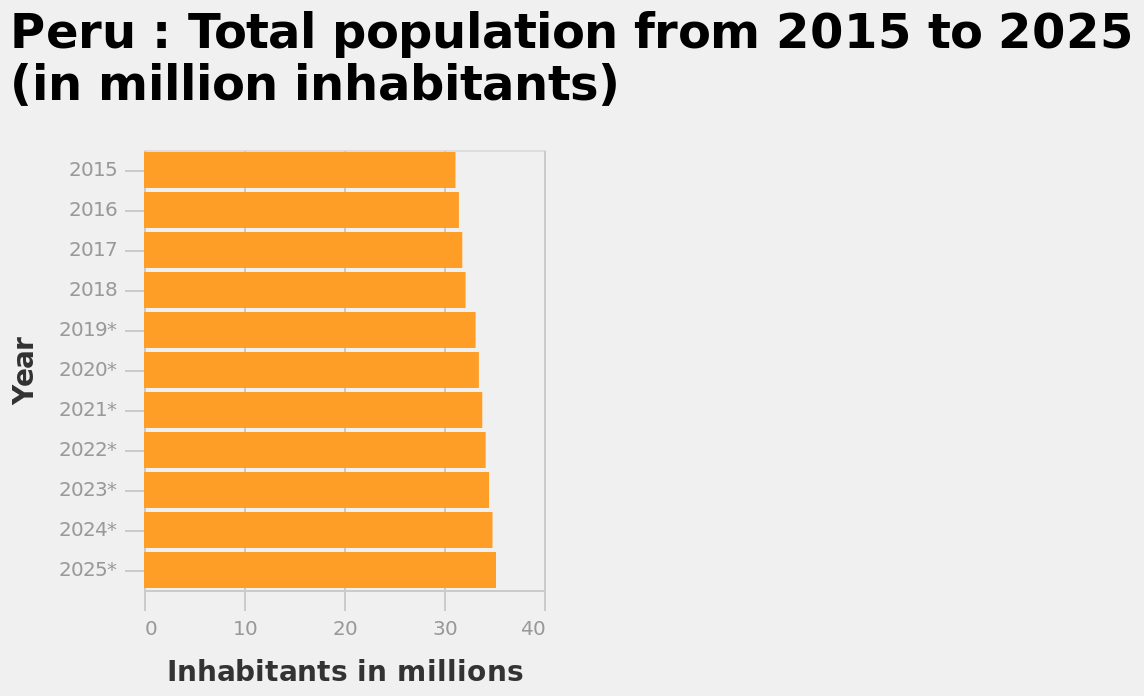<image>
Offer a thorough analysis of the image. The population of Peru has risen steadily from around 31 million in 2009 to  around 32.5 million in 2019.  It is expected to continue rising year-on-year and reach 25 million in 2025. Is the population of Peru expected to continue rising year-on-year? Yes, the population of Peru is expected to continue rising year-on-year. What was the population of Peru in 2009?  The population of Peru was around 31 million in 2009. What is the population trend in Peru from 2015 to 2025?  The population in Peru has been increasing from 2015 to 2025. 